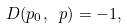Convert formula to latex. <formula><loc_0><loc_0><loc_500><loc_500>D ( p _ { 0 } , \ p ) = - 1 ,</formula> 